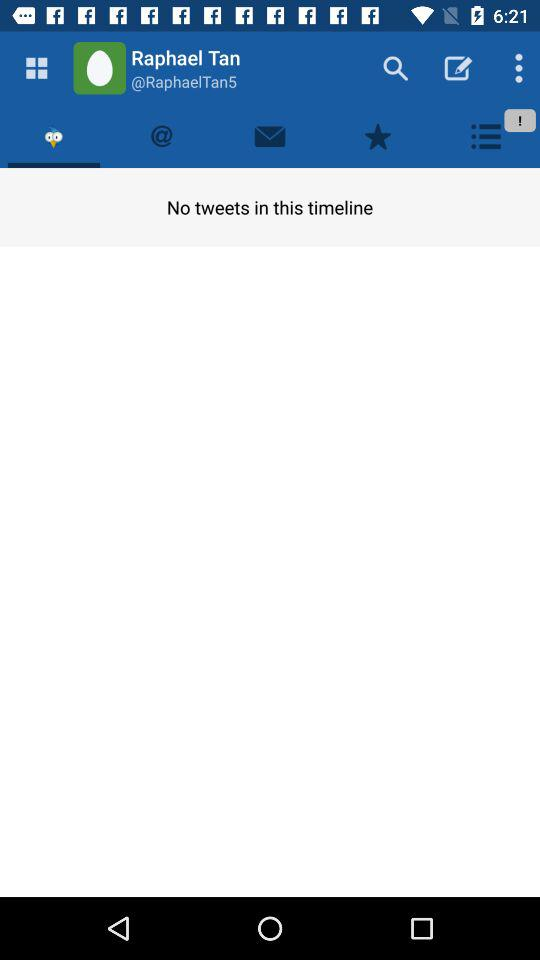What is the user name? The user name is Raphael Tan. 